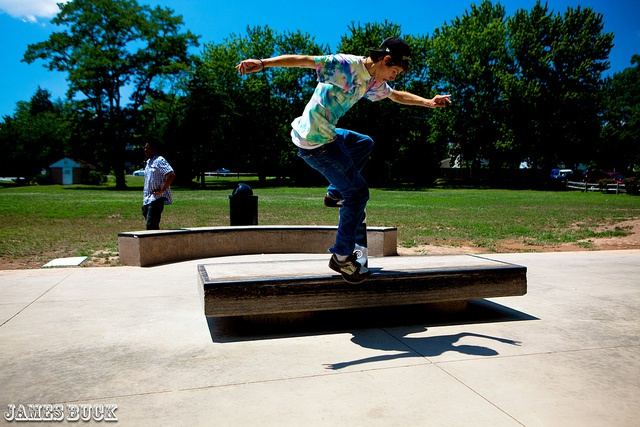Describe the objects in this image and their specific colors. I can see bench in lightblue, black, white, and darkgray tones, people in lightblue, black, gray, white, and maroon tones, people in lightblue, black, navy, gray, and darkgray tones, skateboard in lightblue, black, darkgray, and gray tones, and car in lightblue, black, maroon, navy, and purple tones in this image. 